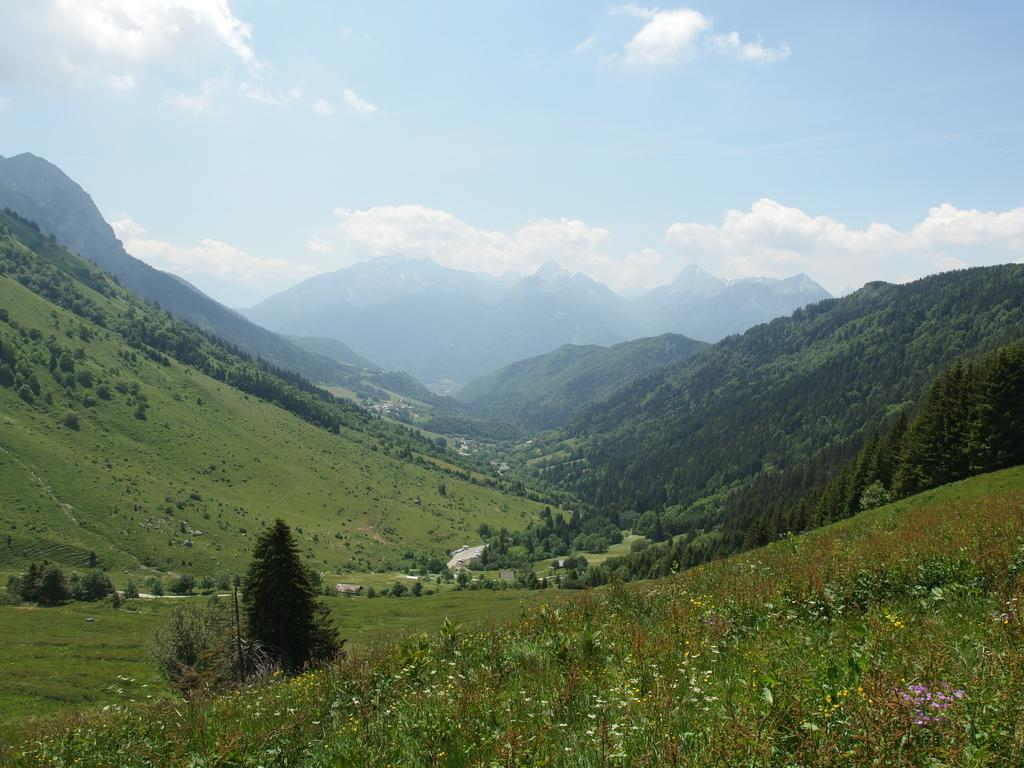What type of natural features can be seen in the image? There are trees and mountains in the image. What is the condition of the sky in the image? The sky is cloudy in the image. How many kittens are playing on the wall in the image? There are no kittens or walls present in the image; it features trees, mountains, and a cloudy sky. 